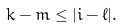<formula> <loc_0><loc_0><loc_500><loc_500>k - m \leq | i - \ell | .</formula> 